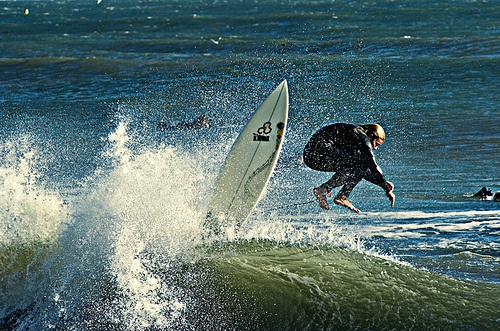Describe the objects in this image and their specific colors. I can see surfboard in darkgray and gray tones, people in darkgray, black, gray, and teal tones, and people in darkgray, black, gray, navy, and blue tones in this image. 